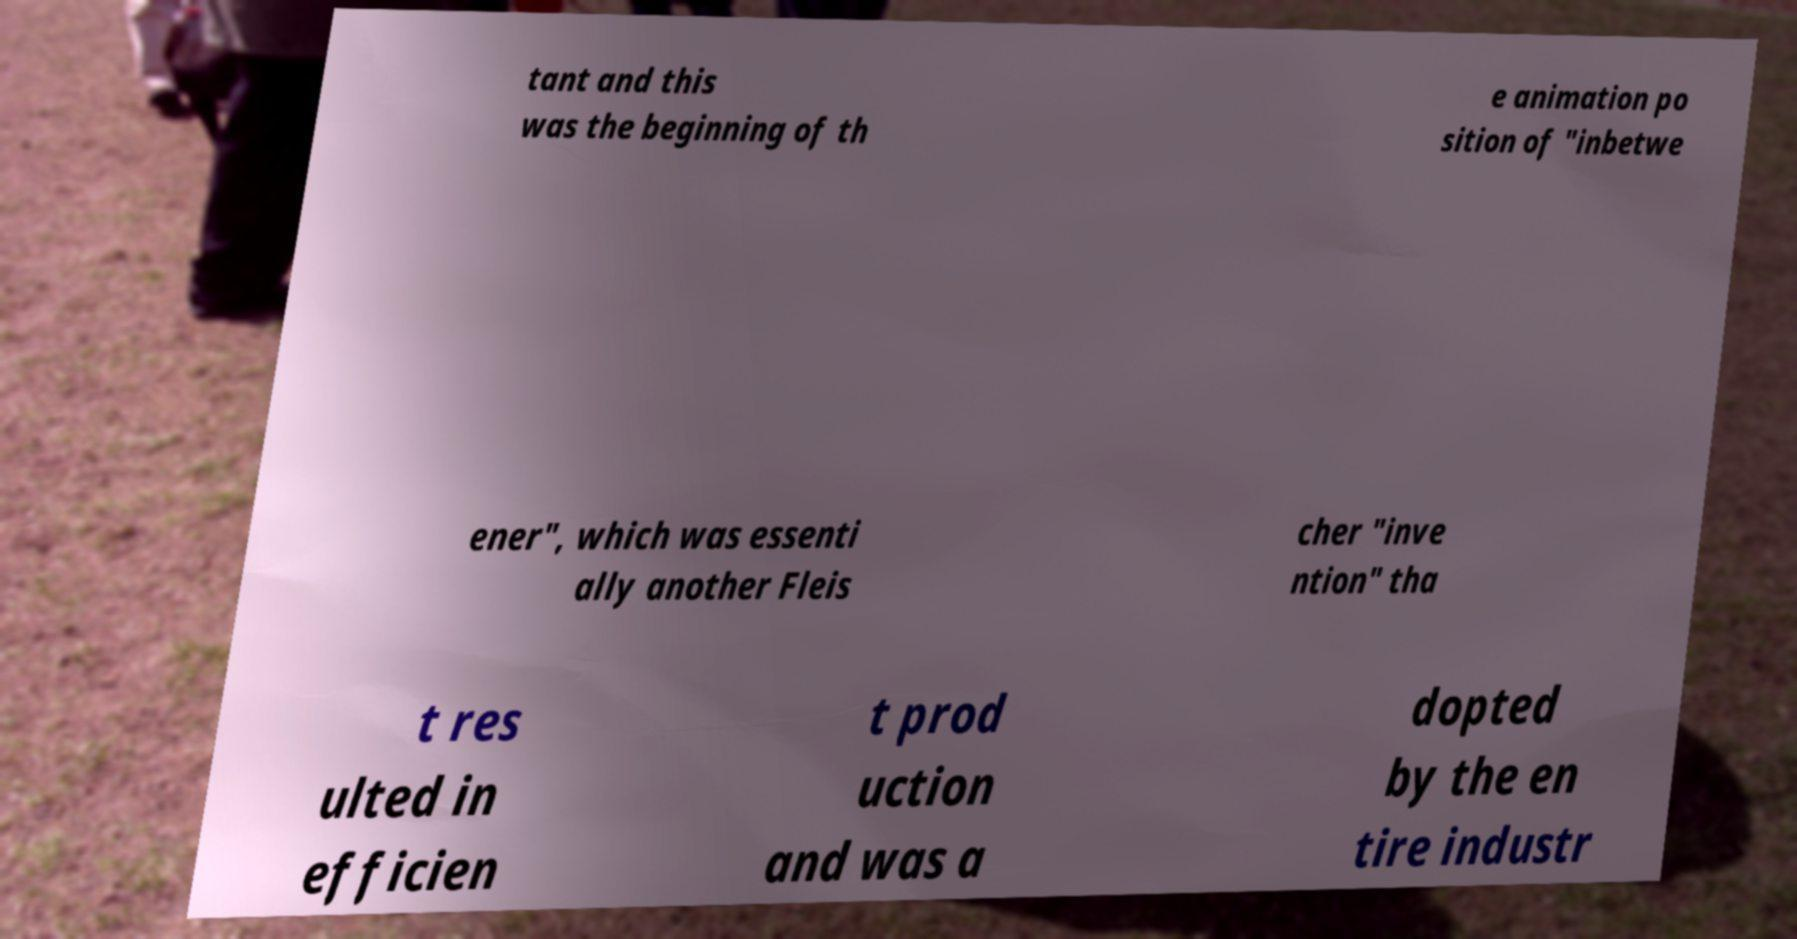I need the written content from this picture converted into text. Can you do that? tant and this was the beginning of th e animation po sition of "inbetwe ener", which was essenti ally another Fleis cher "inve ntion" tha t res ulted in efficien t prod uction and was a dopted by the en tire industr 